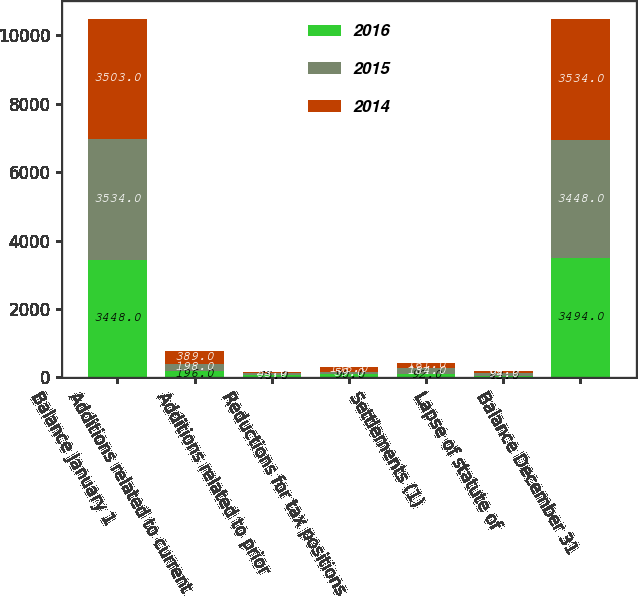Convert chart to OTSL. <chart><loc_0><loc_0><loc_500><loc_500><stacked_bar_chart><ecel><fcel>Balance January 1<fcel>Additions related to current<fcel>Additions related to prior<fcel>Reductions for tax positions<fcel>Settlements (1)<fcel>Lapse of statute of<fcel>Balance December 31<nl><fcel>2016<fcel>3448<fcel>196<fcel>75<fcel>90<fcel>92<fcel>43<fcel>3494<nl><fcel>2015<fcel>3534<fcel>198<fcel>53<fcel>59<fcel>184<fcel>94<fcel>3448<nl><fcel>2014<fcel>3503<fcel>389<fcel>23<fcel>156<fcel>161<fcel>64<fcel>3534<nl></chart> 